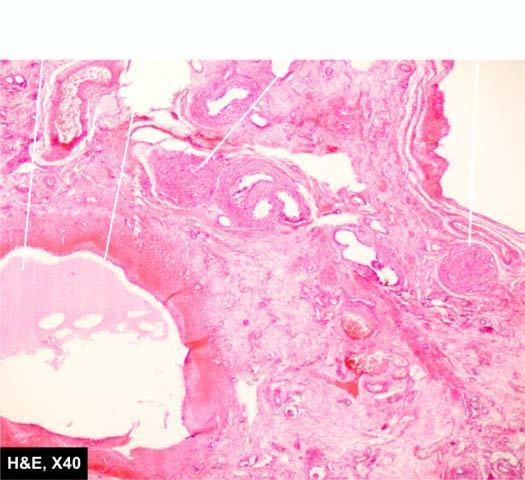re there cysts lined by flattened epithelium while the intervening parenchyma consists of primitive connective tissue and cartilage?
Answer the question using a single word or phrase. Yes 